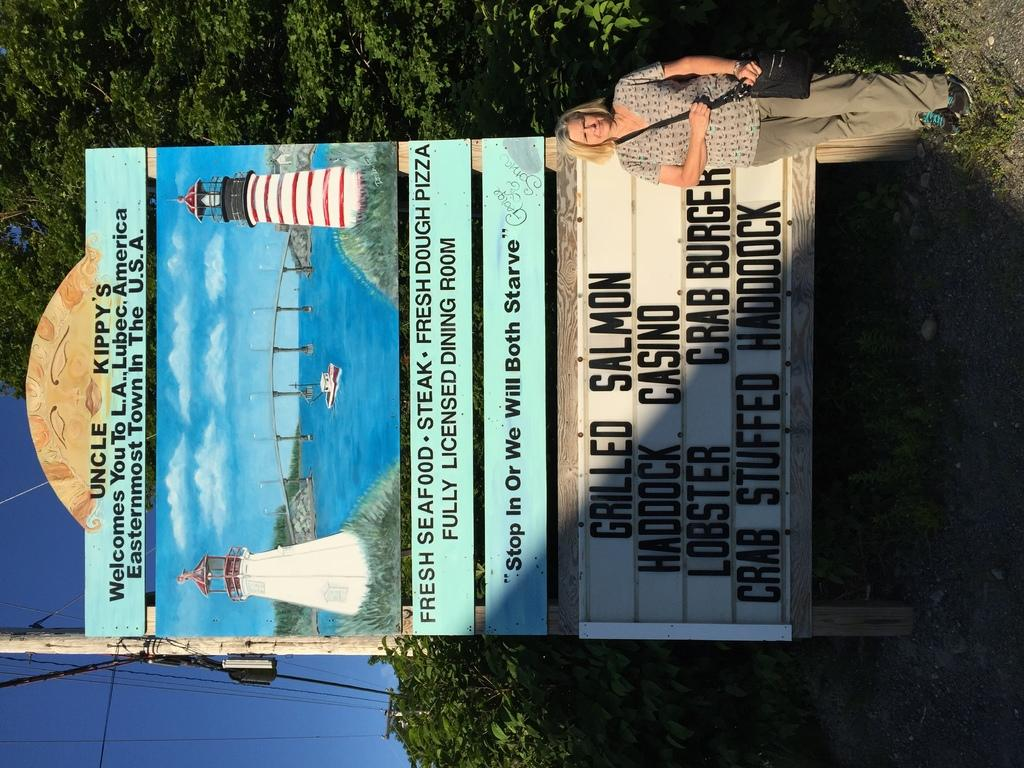Provide a one-sentence caption for the provided image. A restaurant sign stating that one of its specials is grilled salmon. 